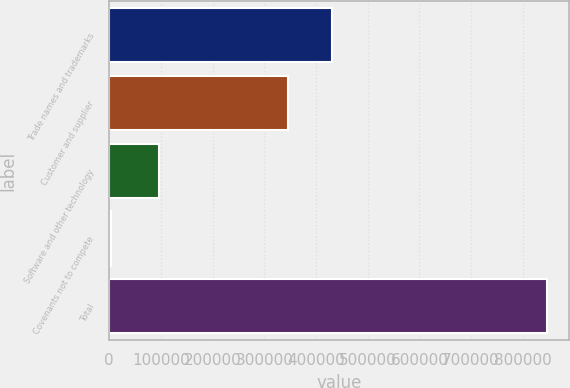<chart> <loc_0><loc_0><loc_500><loc_500><bar_chart><fcel>Trade names and trademarks<fcel>Customer and supplier<fcel>Software and other technology<fcel>Covenants not to compete<fcel>Total<nl><fcel>430513<fcel>346053<fcel>96835<fcel>2849<fcel>847452<nl></chart> 